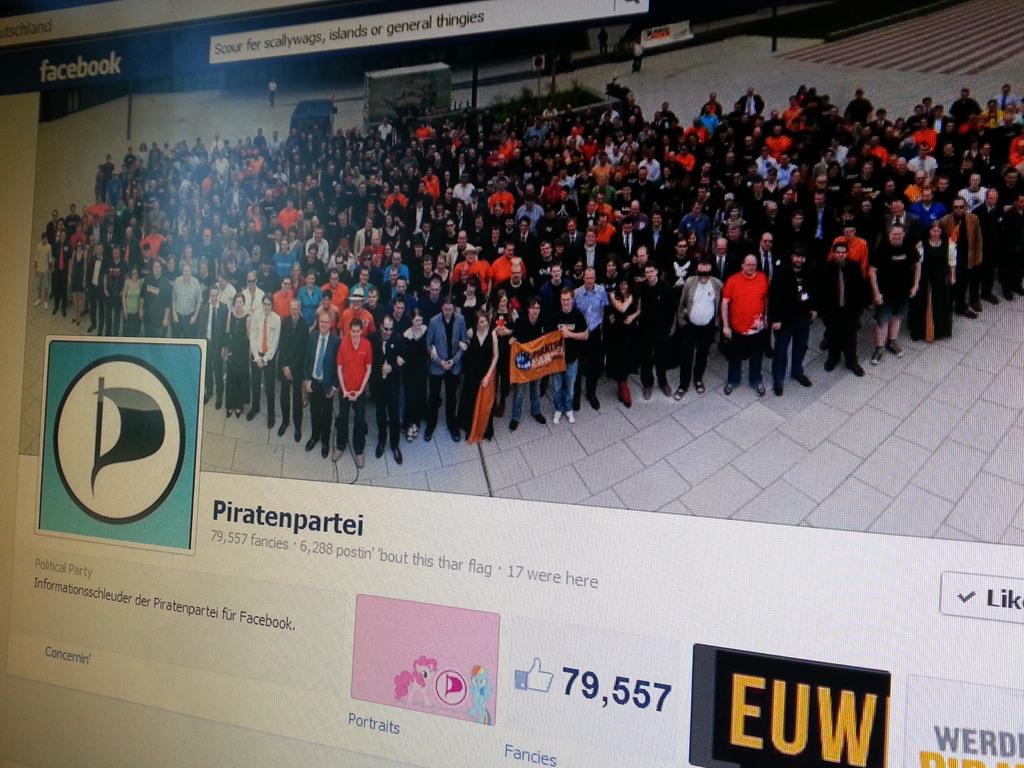Provide a one-sentence caption for the provided image. A Facebook page with 79,557 likes is displayed on the screen. 